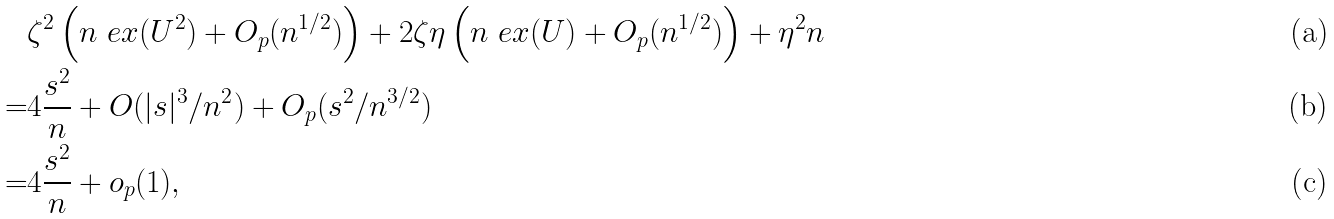Convert formula to latex. <formula><loc_0><loc_0><loc_500><loc_500>& \zeta ^ { 2 } \left ( n \ e x ( U ^ { 2 } ) + O _ { p } ( n ^ { 1 / 2 } ) \right ) + 2 \zeta \eta \left ( n \ e x ( U ) + O _ { p } ( n ^ { 1 / 2 } ) \right ) + \eta ^ { 2 } n \\ = & 4 \frac { s ^ { 2 } } { n } + O ( | s | ^ { 3 } / n ^ { 2 } ) + O _ { p } ( s ^ { 2 } / n ^ { 3 / 2 } ) \\ = & 4 \frac { s ^ { 2 } } { n } + o _ { p } ( 1 ) ,</formula> 